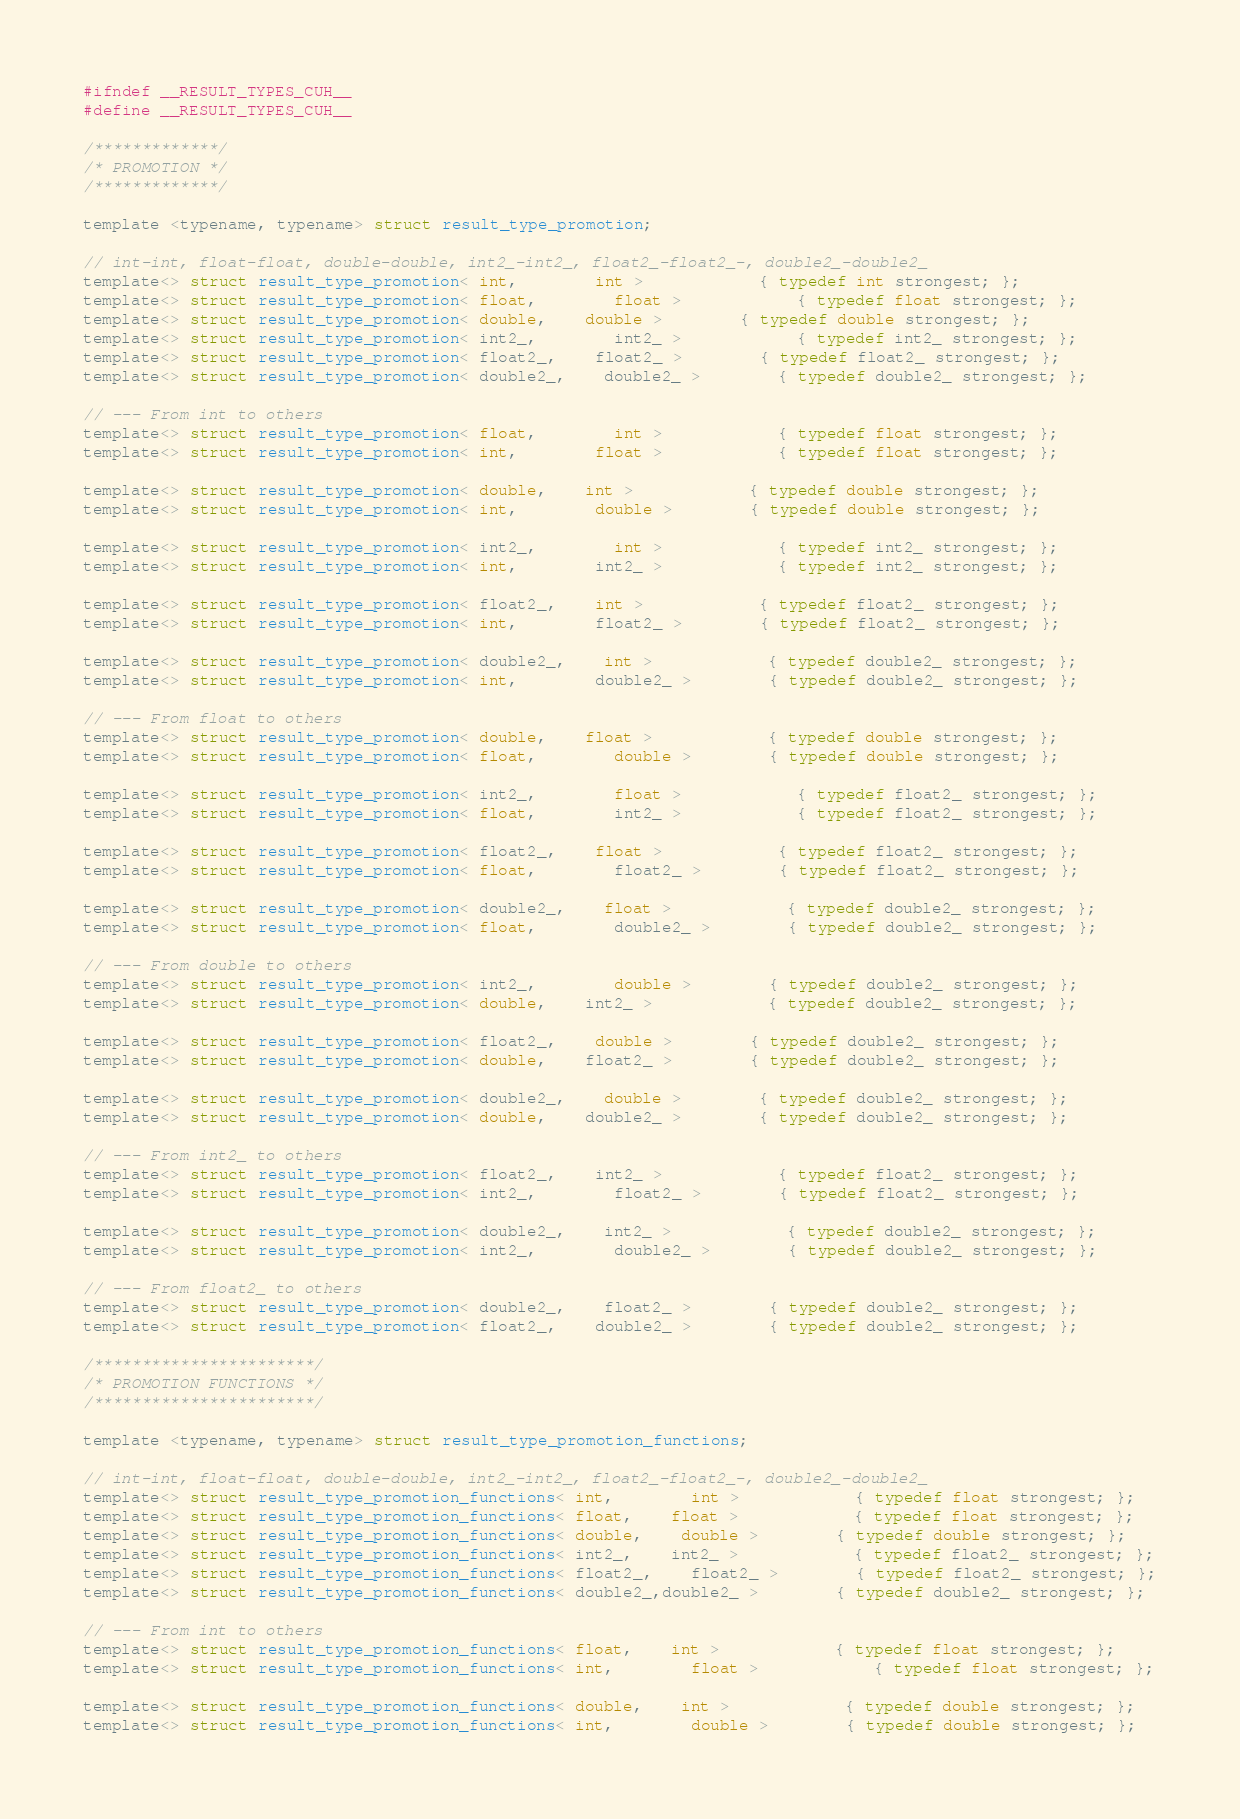Convert code to text. <code><loc_0><loc_0><loc_500><loc_500><_Cuda_>#ifndef __RESULT_TYPES_CUH__
#define __RESULT_TYPES_CUH__

/*************/
/* PROMOTION */
/*************/

template <typename, typename> struct result_type_promotion;

// int-int, float-float, double-double, int2_-int2_, float2_-float2_-, double2_-double2_
template<> struct result_type_promotion< int,		int >			{ typedef int strongest; };
template<> struct result_type_promotion< float,		float >			{ typedef float strongest; };
template<> struct result_type_promotion< double,	double >		{ typedef double strongest; };
template<> struct result_type_promotion< int2_,		int2_ >			{ typedef int2_ strongest; };
template<> struct result_type_promotion< float2_,	float2_ >		{ typedef float2_ strongest; };
template<> struct result_type_promotion< double2_,	double2_ >		{ typedef double2_ strongest; };

// --- From int to others
template<> struct result_type_promotion< float,		int >			{ typedef float strongest; };
template<> struct result_type_promotion< int,		float >			{ typedef float strongest; };

template<> struct result_type_promotion< double,	int >			{ typedef double strongest; };
template<> struct result_type_promotion< int,		double >		{ typedef double strongest; };

template<> struct result_type_promotion< int2_,		int >			{ typedef int2_ strongest; };
template<> struct result_type_promotion< int,		int2_ >			{ typedef int2_ strongest; };

template<> struct result_type_promotion< float2_,	int >			{ typedef float2_ strongest; };
template<> struct result_type_promotion< int,		float2_ >		{ typedef float2_ strongest; };

template<> struct result_type_promotion< double2_,	int >			{ typedef double2_ strongest; };
template<> struct result_type_promotion< int,		double2_ >		{ typedef double2_ strongest; };

// --- From float to others
template<> struct result_type_promotion< double,	float >			{ typedef double strongest; };
template<> struct result_type_promotion< float,		double >		{ typedef double strongest; };

template<> struct result_type_promotion< int2_,		float >			{ typedef float2_ strongest; };
template<> struct result_type_promotion< float,		int2_ >			{ typedef float2_ strongest; };

template<> struct result_type_promotion< float2_,	float >			{ typedef float2_ strongest; };
template<> struct result_type_promotion< float,		float2_ >		{ typedef float2_ strongest; };

template<> struct result_type_promotion< double2_,	float >			{ typedef double2_ strongest; };
template<> struct result_type_promotion< float,		double2_ >		{ typedef double2_ strongest; };

// --- From double to others
template<> struct result_type_promotion< int2_,		double >		{ typedef double2_ strongest; };
template<> struct result_type_promotion< double,	int2_ >			{ typedef double2_ strongest; };

template<> struct result_type_promotion< float2_,	double >		{ typedef double2_ strongest; };
template<> struct result_type_promotion< double,	float2_ >		{ typedef double2_ strongest; };

template<> struct result_type_promotion< double2_,	double >		{ typedef double2_ strongest; };
template<> struct result_type_promotion< double,	double2_ >		{ typedef double2_ strongest; };

// --- From int2_ to others
template<> struct result_type_promotion< float2_,	int2_ >			{ typedef float2_ strongest; };
template<> struct result_type_promotion< int2_,		float2_ >		{ typedef float2_ strongest; };

template<> struct result_type_promotion< double2_,	int2_ >			{ typedef double2_ strongest; };
template<> struct result_type_promotion< int2_,		double2_ >		{ typedef double2_ strongest; };

// --- From float2_ to others
template<> struct result_type_promotion< double2_,	float2_ >		{ typedef double2_ strongest; };
template<> struct result_type_promotion< float2_,	double2_ >		{ typedef double2_ strongest; };

/***********************/
/* PROMOTION FUNCTIONS */
/***********************/

template <typename, typename> struct result_type_promotion_functions;

// int-int, float-float, double-double, int2_-int2_, float2_-float2_-, double2_-double2_
template<> struct result_type_promotion_functions< int,		int >			{ typedef float strongest; };
template<> struct result_type_promotion_functions< float,	float >			{ typedef float strongest; };
template<> struct result_type_promotion_functions< double,	double >		{ typedef double strongest; };
template<> struct result_type_promotion_functions< int2_,	int2_ >			{ typedef float2_ strongest; };
template<> struct result_type_promotion_functions< float2_,	float2_ >		{ typedef float2_ strongest; };
template<> struct result_type_promotion_functions< double2_,double2_ >		{ typedef double2_ strongest; };

// --- From int to others
template<> struct result_type_promotion_functions< float,	int >			{ typedef float strongest; };
template<> struct result_type_promotion_functions< int,		float >			{ typedef float strongest; };

template<> struct result_type_promotion_functions< double,	int >			{ typedef double strongest; };
template<> struct result_type_promotion_functions< int,		double >		{ typedef double strongest; };
</code> 